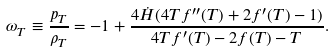<formula> <loc_0><loc_0><loc_500><loc_500>\omega _ { T } \equiv \frac { p _ { T } } { \rho _ { T } } = - 1 + \frac { 4 \dot { H } ( 4 T f ^ { \prime \prime } ( T ) + 2 f ^ { \prime } ( T ) - 1 ) } { 4 T f ^ { \prime } ( T ) - 2 f ( T ) - T } .</formula> 